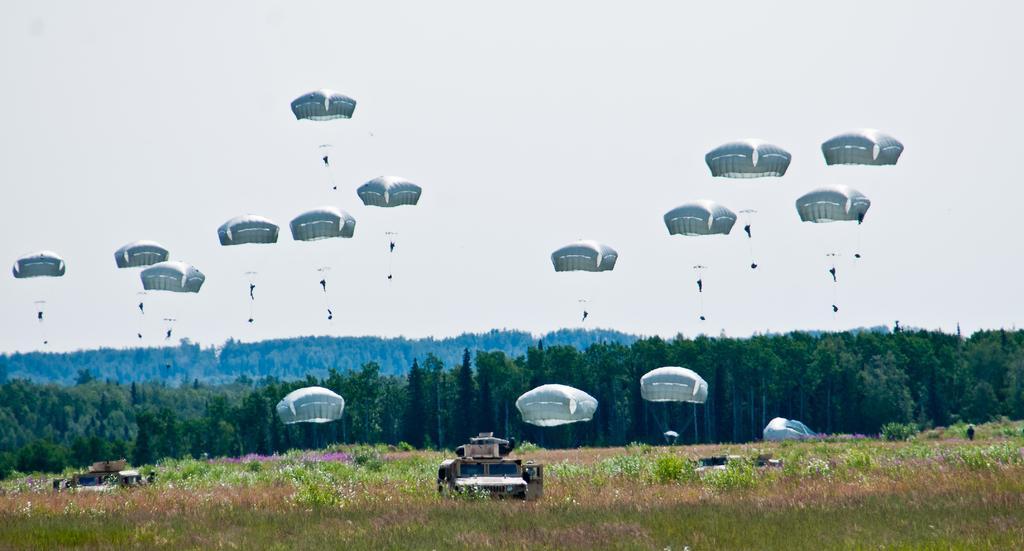In one or two sentences, can you explain what this image depicts? In this image there are vehicles, on a grassland and there are plants, in the background there are trees and the sky and few people are parachuting. 